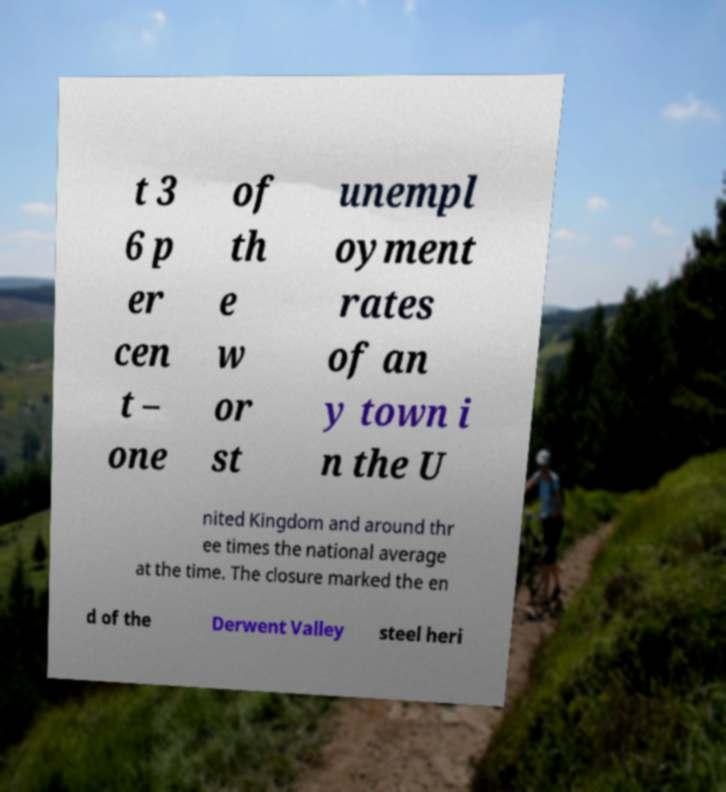Can you accurately transcribe the text from the provided image for me? t 3 6 p er cen t – one of th e w or st unempl oyment rates of an y town i n the U nited Kingdom and around thr ee times the national average at the time. The closure marked the en d of the Derwent Valley steel heri 